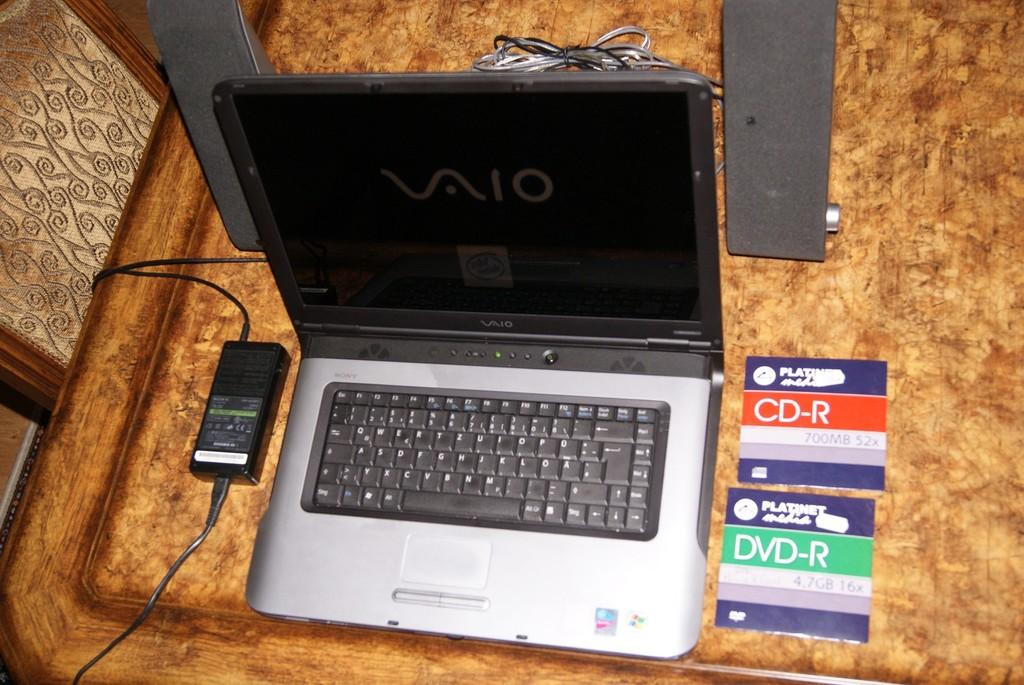<image>
Give a short and clear explanation of the subsequent image. A laptop opened up next to CD-R and DVD-R cases. 